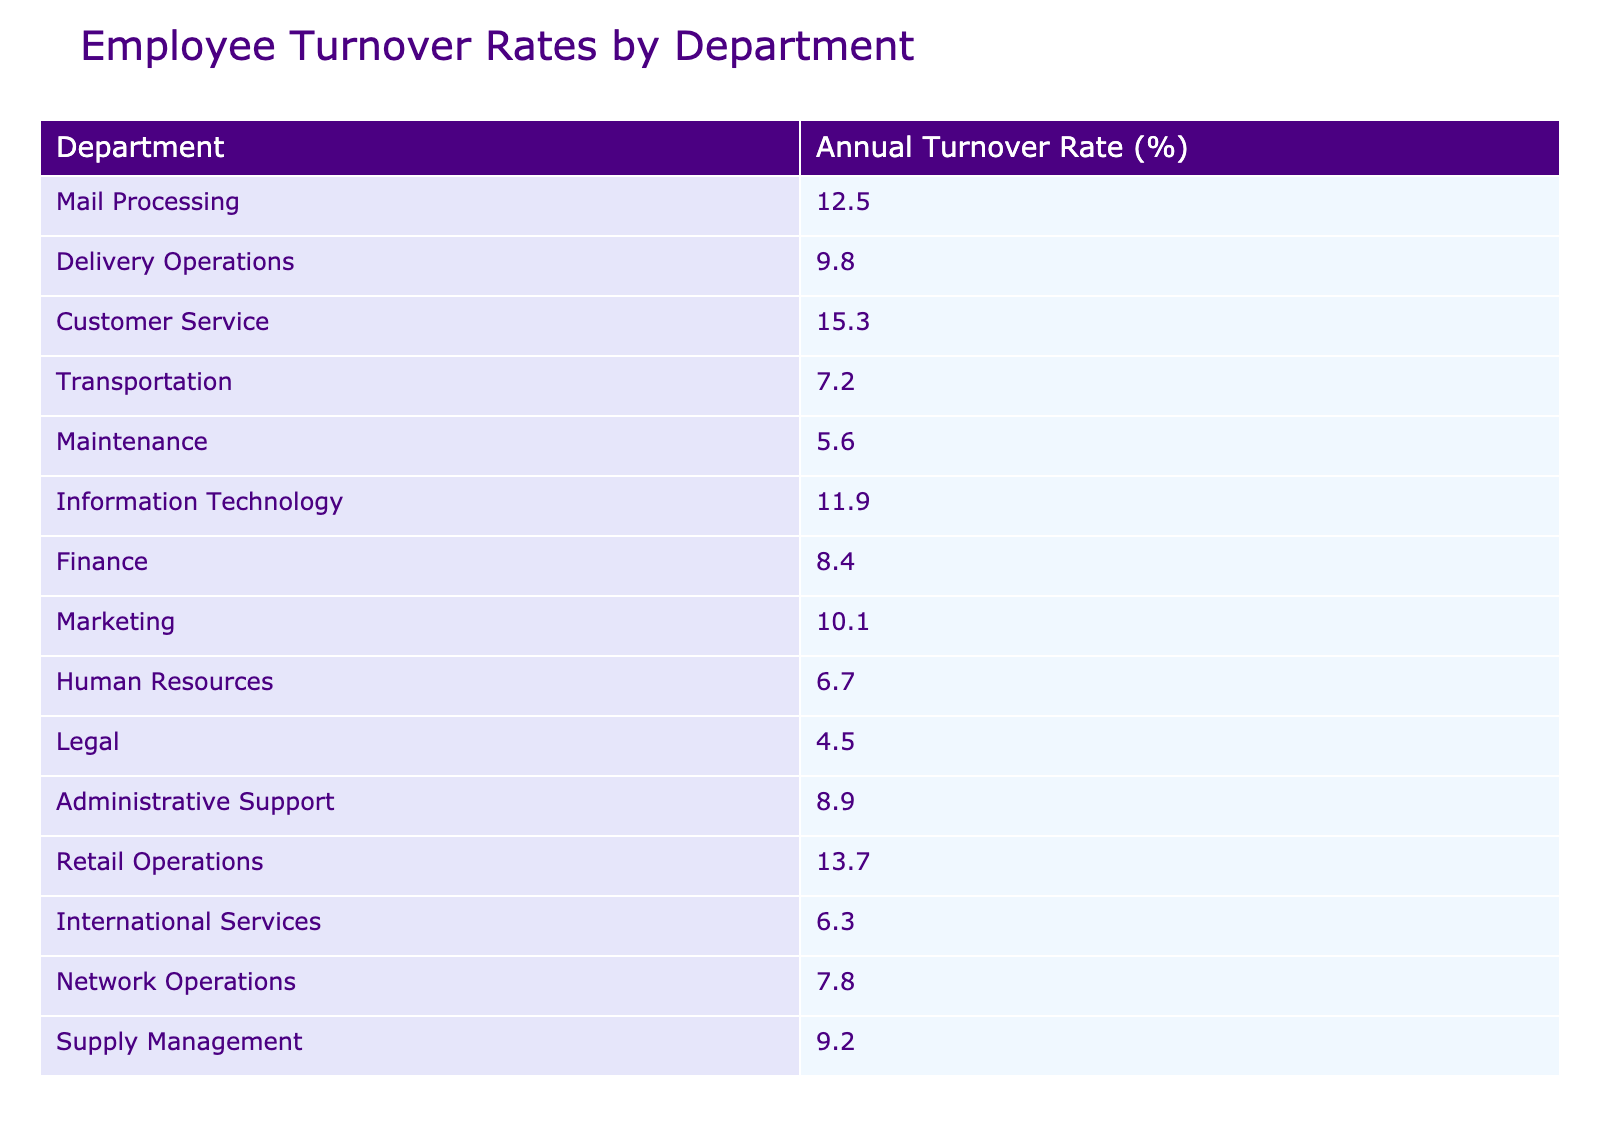What is the annual turnover rate for the Customer Service department? The table shows a turnover rate of 15.3% specifically for the Customer Service department.
Answer: 15.3% Which department has the highest turnover rate? By comparing the turnover rates listed in the table, Customer Service has the highest rate at 15.3%.
Answer: Customer Service What is the average turnover rate for the Maintenance, Information Technology, and Human Resources departments? The turnover rates for these departments are 5.6%, 11.9%, and 6.7%. First, sum these values: 5.6 + 11.9 + 6.7 = 24.2. Then, divide by the number of departments (3): 24.2 / 3 = 8.07.
Answer: 8.07 Is the turnover rate for Delivery Operations greater than 10%? Delivery Operations has a turnover rate of 9.8%, which is less than 10%. Therefore, the answer is no.
Answer: No What is the difference between the turnover rates of the Legal and Transportation departments? The turnover rate for Legal is 4.5%, and for Transportation, it is 7.2%. To find the difference, subtract: 7.2 - 4.5 = 2.7.
Answer: 2.7 Which two departments have turnover rates below 7%? The table presents turnover rates for Legal at 4.5% and Maintenance at 5.6%. Both are below 7%.
Answer: Legal and Maintenance If the turnover rates for the top three departments with the highest rates (Customer Service, Retail Operations, and Mail Processing) are summed, what is the total? The turnover rates are: Customer Service (15.3%), Retail Operations (13.7%), and Mail Processing (12.5%). Adding these gives: 15.3 + 13.7 + 12.5 = 41.5.
Answer: 41.5 How many departments have turnover rates below 10%? Looking at the table, the departments with rates below 10% are: Transportation (7.2%), Maintenance (5.6%), Legal (4.5%), Human Resources (6.7%), and International Services (6.3%). This totals to 5 departments.
Answer: 5 Is the average turnover rate across all departments greater than 10%? First, we add all turnover rates and count the departments. Total turnover = 12.5 + 9.8 + 15.3 + 7.2 + 5.6 + 11.9 + 8.4 + 10.1 + 6.7 + 4.5 + 8.9 + 13.7 + 6.3 + 7.8 + 9.2 =  102.4. There are 15 departments, so average = 102.4 / 15 = 6.83, which is less than 10%.
Answer: No 